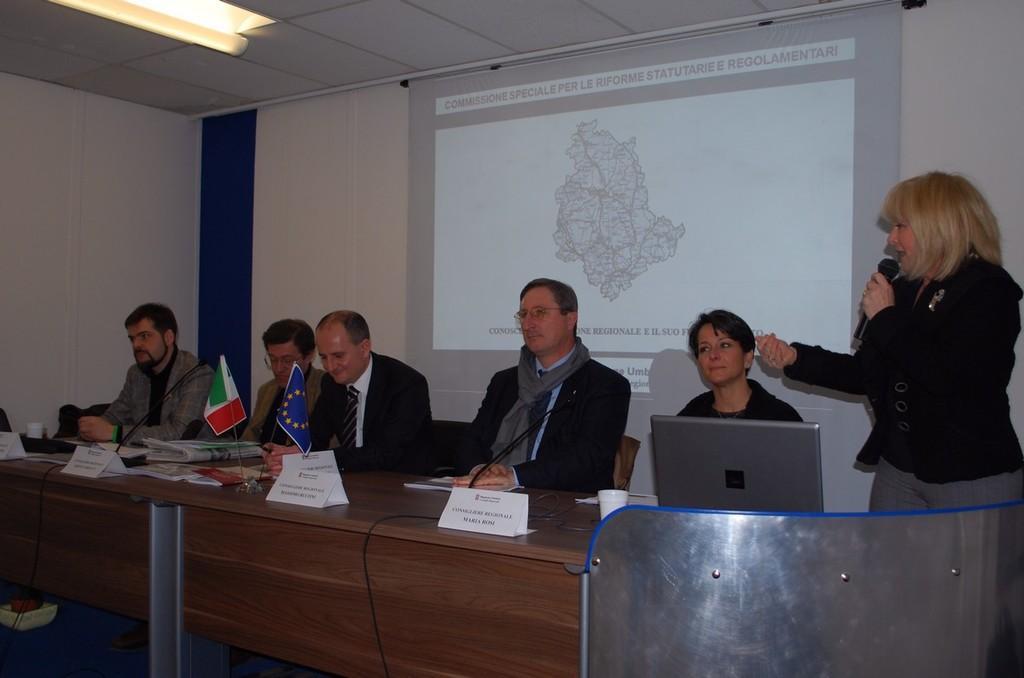Please provide a concise description of this image. In this picture there are five people sitting on chairs and woman standing and holding a microphone. We can see laptop, microphones, name boards, flags, papers and objects on the table. In the background of the image we can see screen and wall. At the top of the image we can see lights. 